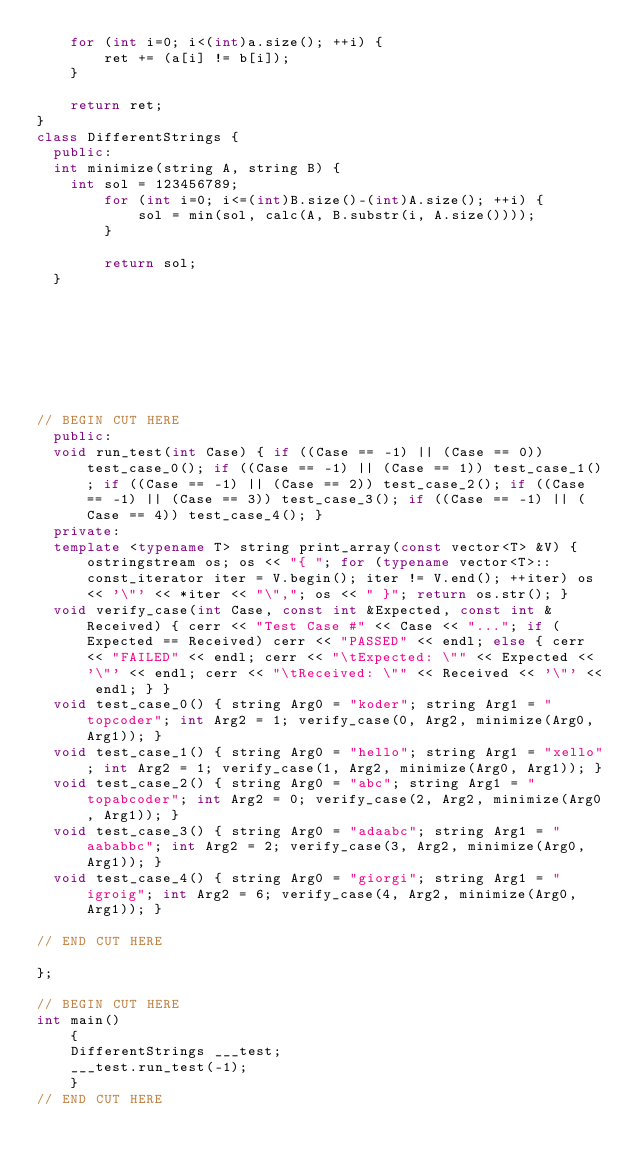<code> <loc_0><loc_0><loc_500><loc_500><_C++_>    for (int i=0; i<(int)a.size(); ++i) {
        ret += (a[i] != b[i]);
    }
    
    return ret;
}
class DifferentStrings {
	public:
	int minimize(string A, string B) {
		int sol = 123456789;
        for (int i=0; i<=(int)B.size()-(int)A.size(); ++i) {
            sol = min(sol, calc(A, B.substr(i, A.size())));
        }
        
        return sol;
	}







   
// BEGIN CUT HERE
	public:
	void run_test(int Case) { if ((Case == -1) || (Case == 0)) test_case_0(); if ((Case == -1) || (Case == 1)) test_case_1(); if ((Case == -1) || (Case == 2)) test_case_2(); if ((Case == -1) || (Case == 3)) test_case_3(); if ((Case == -1) || (Case == 4)) test_case_4(); }
	private:
	template <typename T> string print_array(const vector<T> &V) { ostringstream os; os << "{ "; for (typename vector<T>::const_iterator iter = V.begin(); iter != V.end(); ++iter) os << '\"' << *iter << "\","; os << " }"; return os.str(); }
	void verify_case(int Case, const int &Expected, const int &Received) { cerr << "Test Case #" << Case << "..."; if (Expected == Received) cerr << "PASSED" << endl; else { cerr << "FAILED" << endl; cerr << "\tExpected: \"" << Expected << '\"' << endl; cerr << "\tReceived: \"" << Received << '\"' << endl; } }
	void test_case_0() { string Arg0 = "koder"; string Arg1 = "topcoder"; int Arg2 = 1; verify_case(0, Arg2, minimize(Arg0, Arg1)); }
	void test_case_1() { string Arg0 = "hello"; string Arg1 = "xello"; int Arg2 = 1; verify_case(1, Arg2, minimize(Arg0, Arg1)); }
	void test_case_2() { string Arg0 = "abc"; string Arg1 = "topabcoder"; int Arg2 = 0; verify_case(2, Arg2, minimize(Arg0, Arg1)); }
	void test_case_3() { string Arg0 = "adaabc"; string Arg1 = "aababbc"; int Arg2 = 2; verify_case(3, Arg2, minimize(Arg0, Arg1)); }
	void test_case_4() { string Arg0 = "giorgi"; string Arg1 = "igroig"; int Arg2 = 6; verify_case(4, Arg2, minimize(Arg0, Arg1)); }

// END CUT HERE
 
};

// BEGIN CUT HERE 
int main()
    {
    DifferentStrings ___test; 
    ___test.run_test(-1); 
    } 
// END CUT HERE
</code> 